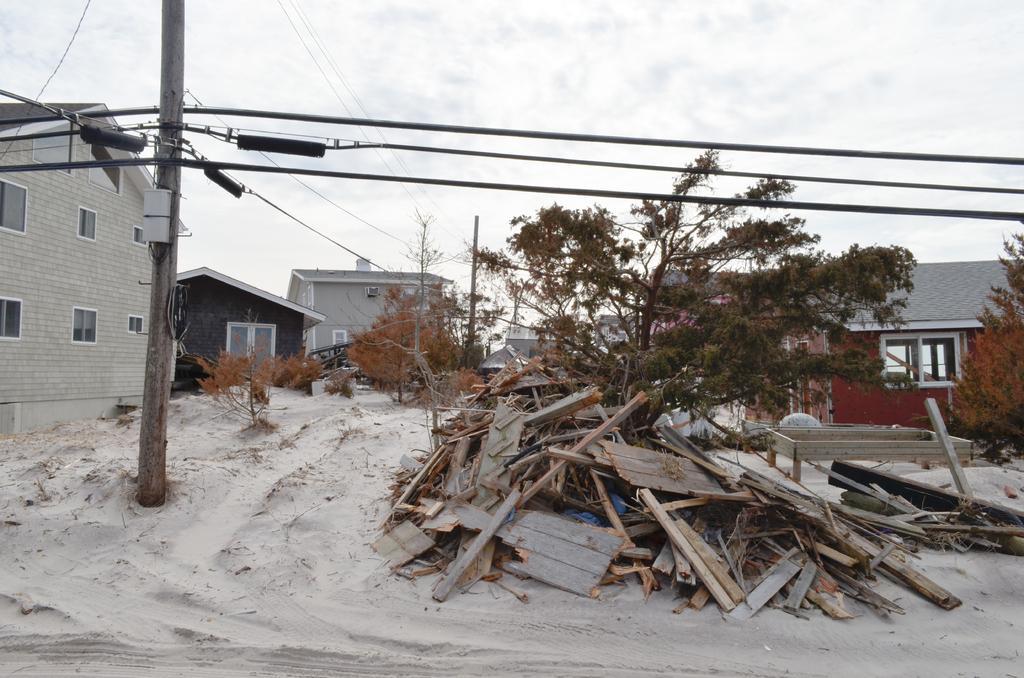Please provide a concise description of this image. There is a pole with wires. On the ground there is sand and wooden pieces. Also there are trees. And there are buildings with windows. In the background there is sky. 